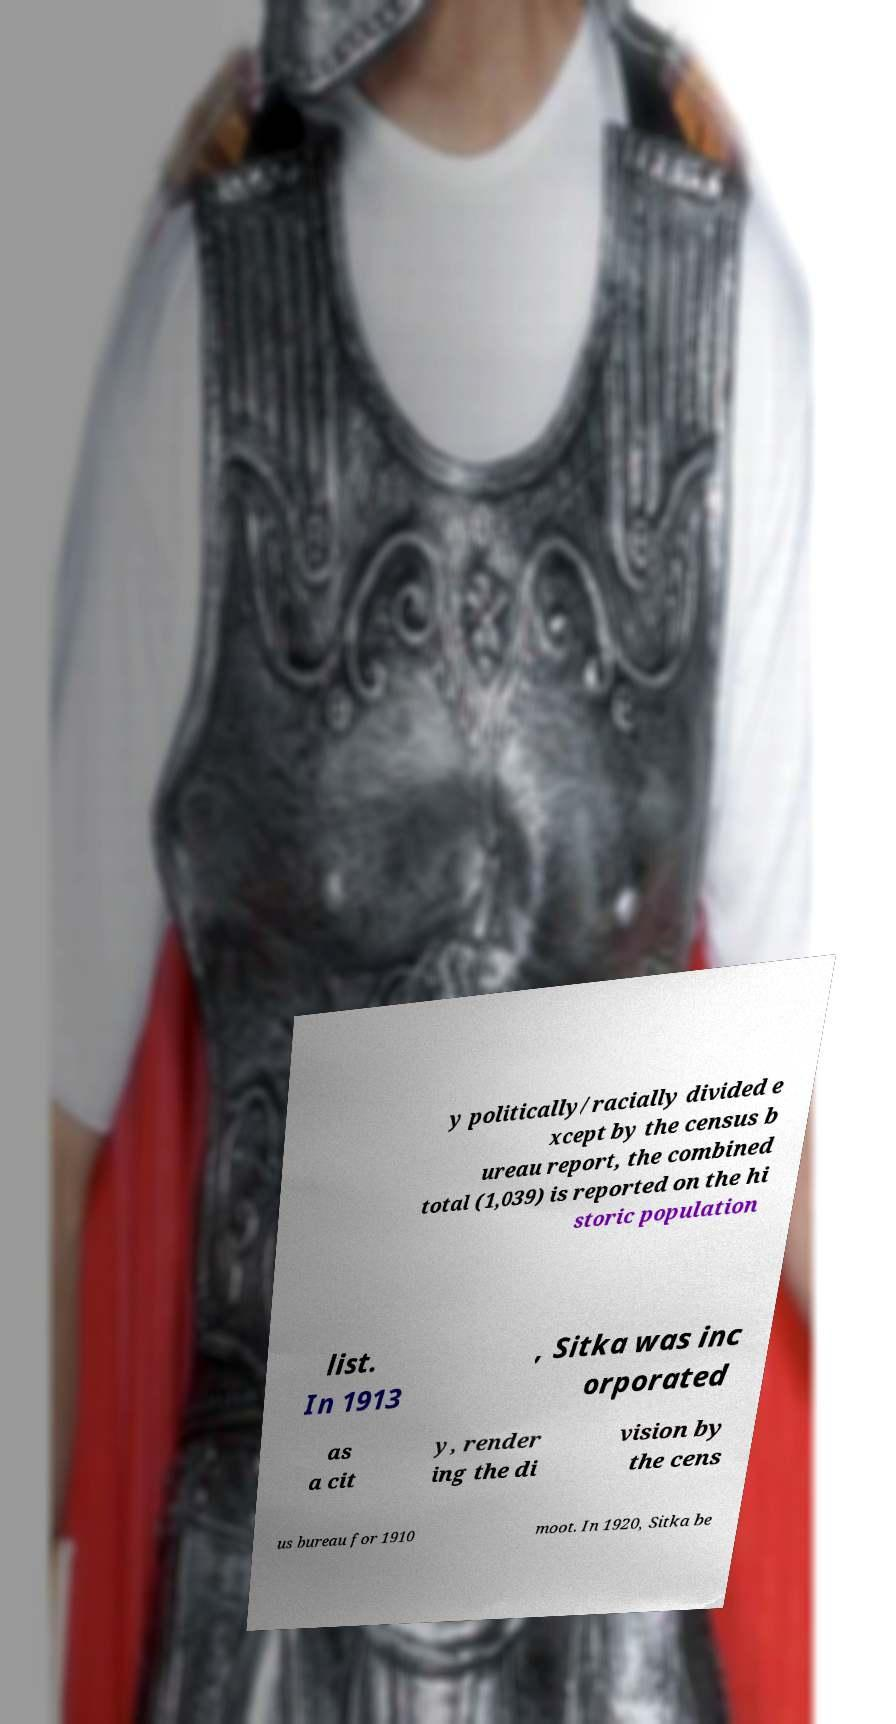Can you read and provide the text displayed in the image?This photo seems to have some interesting text. Can you extract and type it out for me? y politically/racially divided e xcept by the census b ureau report, the combined total (1,039) is reported on the hi storic population list. In 1913 , Sitka was inc orporated as a cit y, render ing the di vision by the cens us bureau for 1910 moot. In 1920, Sitka be 